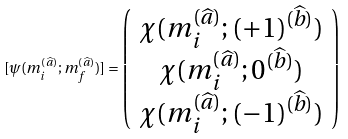Convert formula to latex. <formula><loc_0><loc_0><loc_500><loc_500>[ \psi ( m _ { i } ^ { ( \widehat { a } ) } ; m _ { f } ^ { ( \widehat { a } ) } ) ] = \left ( \begin{array} { c } \chi ( m _ { i } ^ { ( \widehat { a } ) } ; ( + 1 ) ^ { ( \widehat { b } ) } ) \\ \chi ( m _ { i } ^ { ( \widehat { a } ) } ; 0 ^ { ( \widehat { b } ) } ) \\ \chi ( m _ { i } ^ { ( \widehat { a } ) } ; ( - 1 ) ^ { ( \widehat { b } ) } ) \end{array} \right )</formula> 